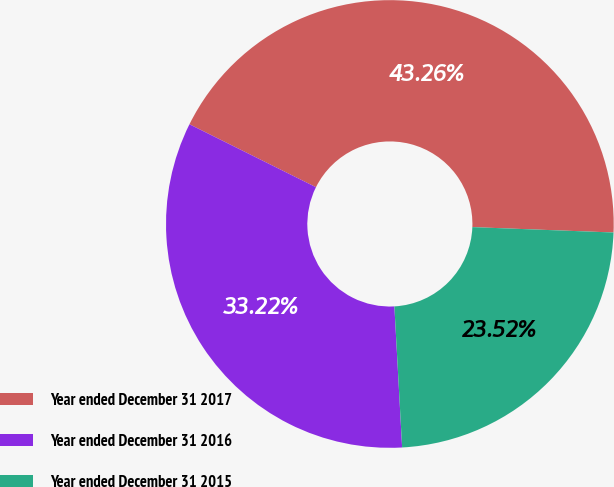Convert chart to OTSL. <chart><loc_0><loc_0><loc_500><loc_500><pie_chart><fcel>Year ended December 31 2017<fcel>Year ended December 31 2016<fcel>Year ended December 31 2015<nl><fcel>43.26%<fcel>33.22%<fcel>23.52%<nl></chart> 